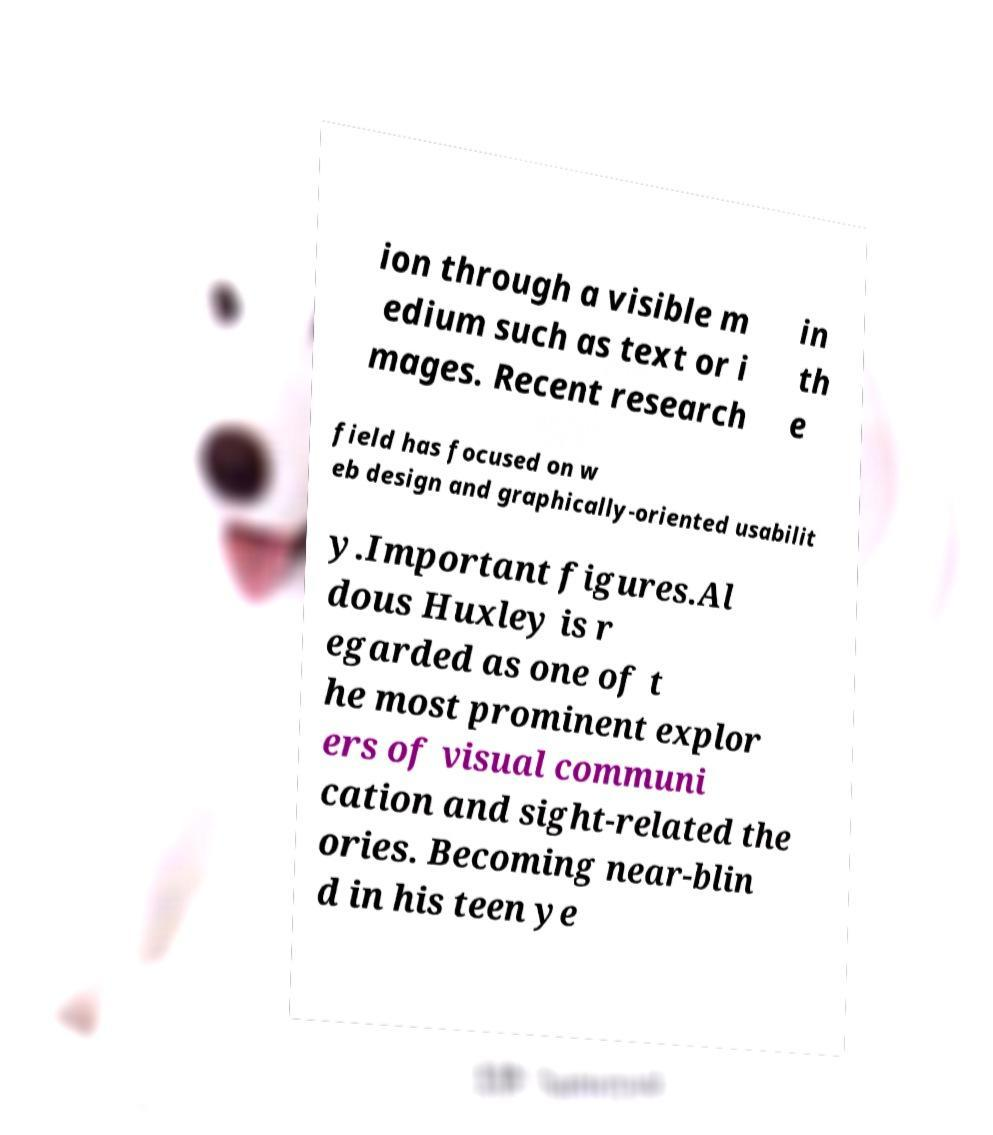Please identify and transcribe the text found in this image. ion through a visible m edium such as text or i mages. Recent research in th e field has focused on w eb design and graphically-oriented usabilit y.Important figures.Al dous Huxley is r egarded as one of t he most prominent explor ers of visual communi cation and sight-related the ories. Becoming near-blin d in his teen ye 